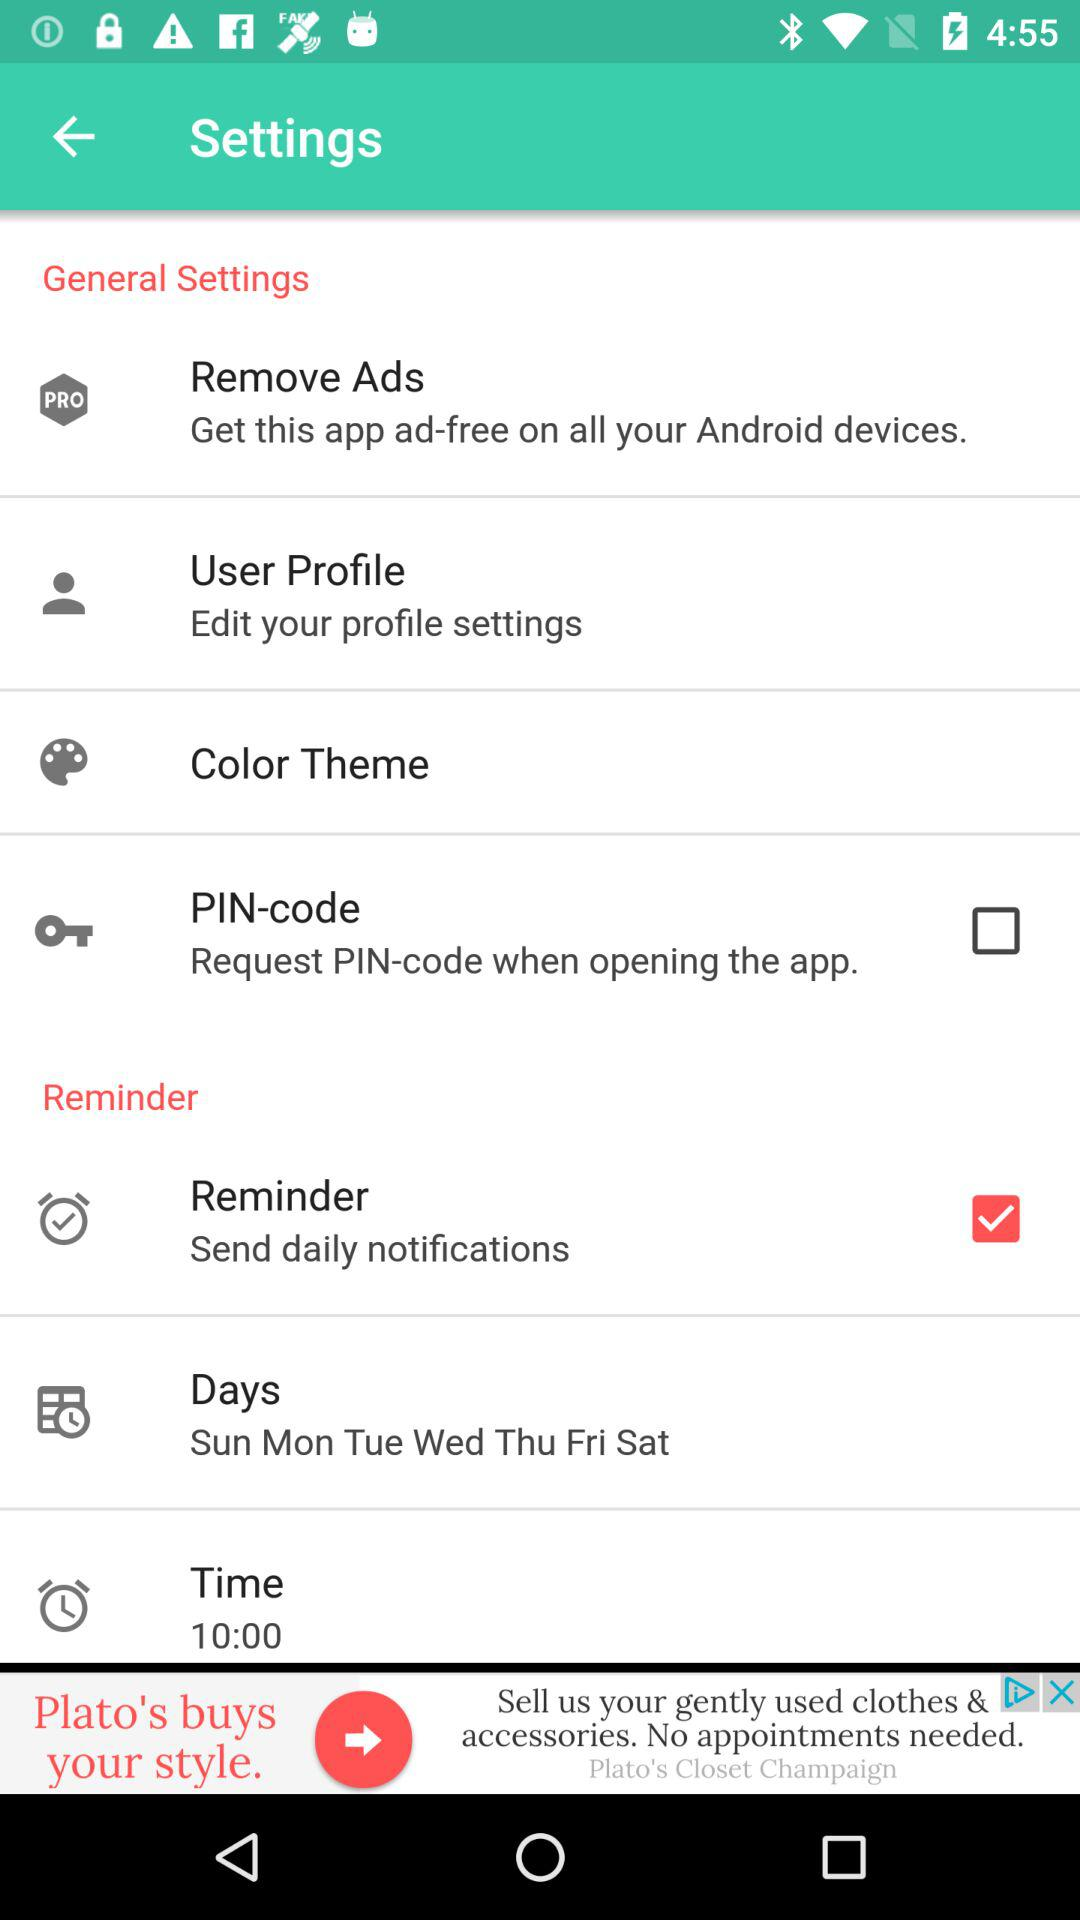For what days is the reminder set? The reminder is set for "Sun Mon Tue Wed Thu Fri Sat". 